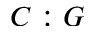<formula> <loc_0><loc_0><loc_500><loc_500>C \colon G</formula> 